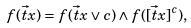Convert formula to latex. <formula><loc_0><loc_0><loc_500><loc_500>f ( \vec { t } { x } ) = f ( \vec { t } { x } \vee c ) \wedge f ( [ \vec { t } { x } ] ^ { c } ) ,</formula> 